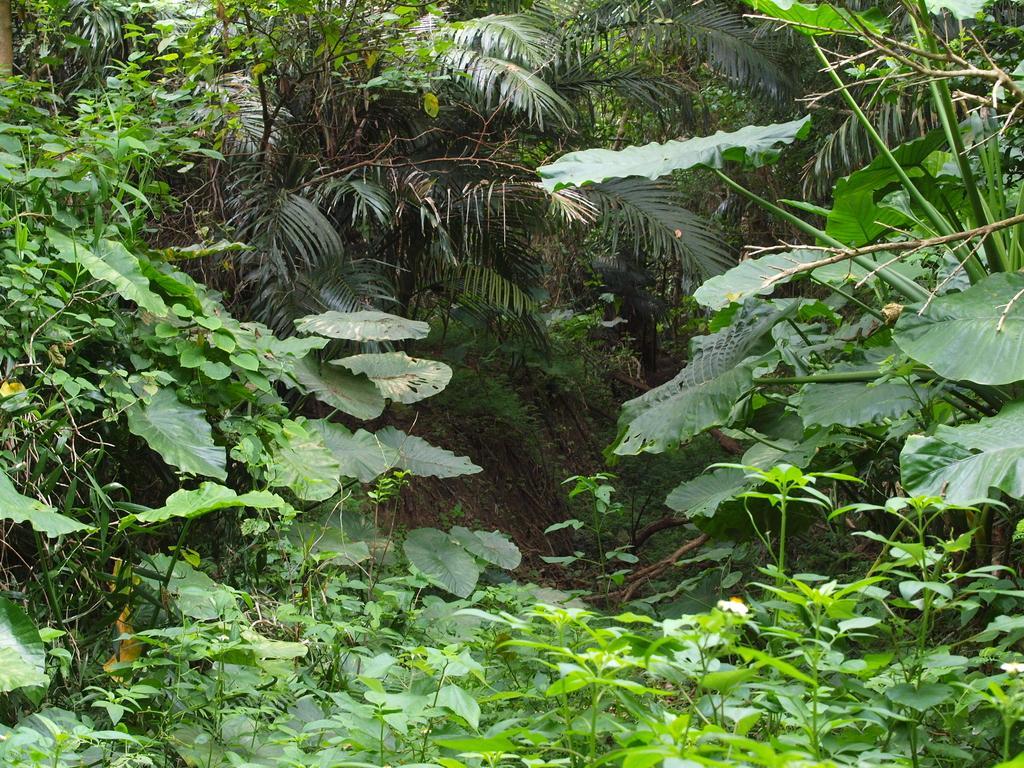Please provide a concise description of this image. In the image we can see grass and leaves of different shape and size. 